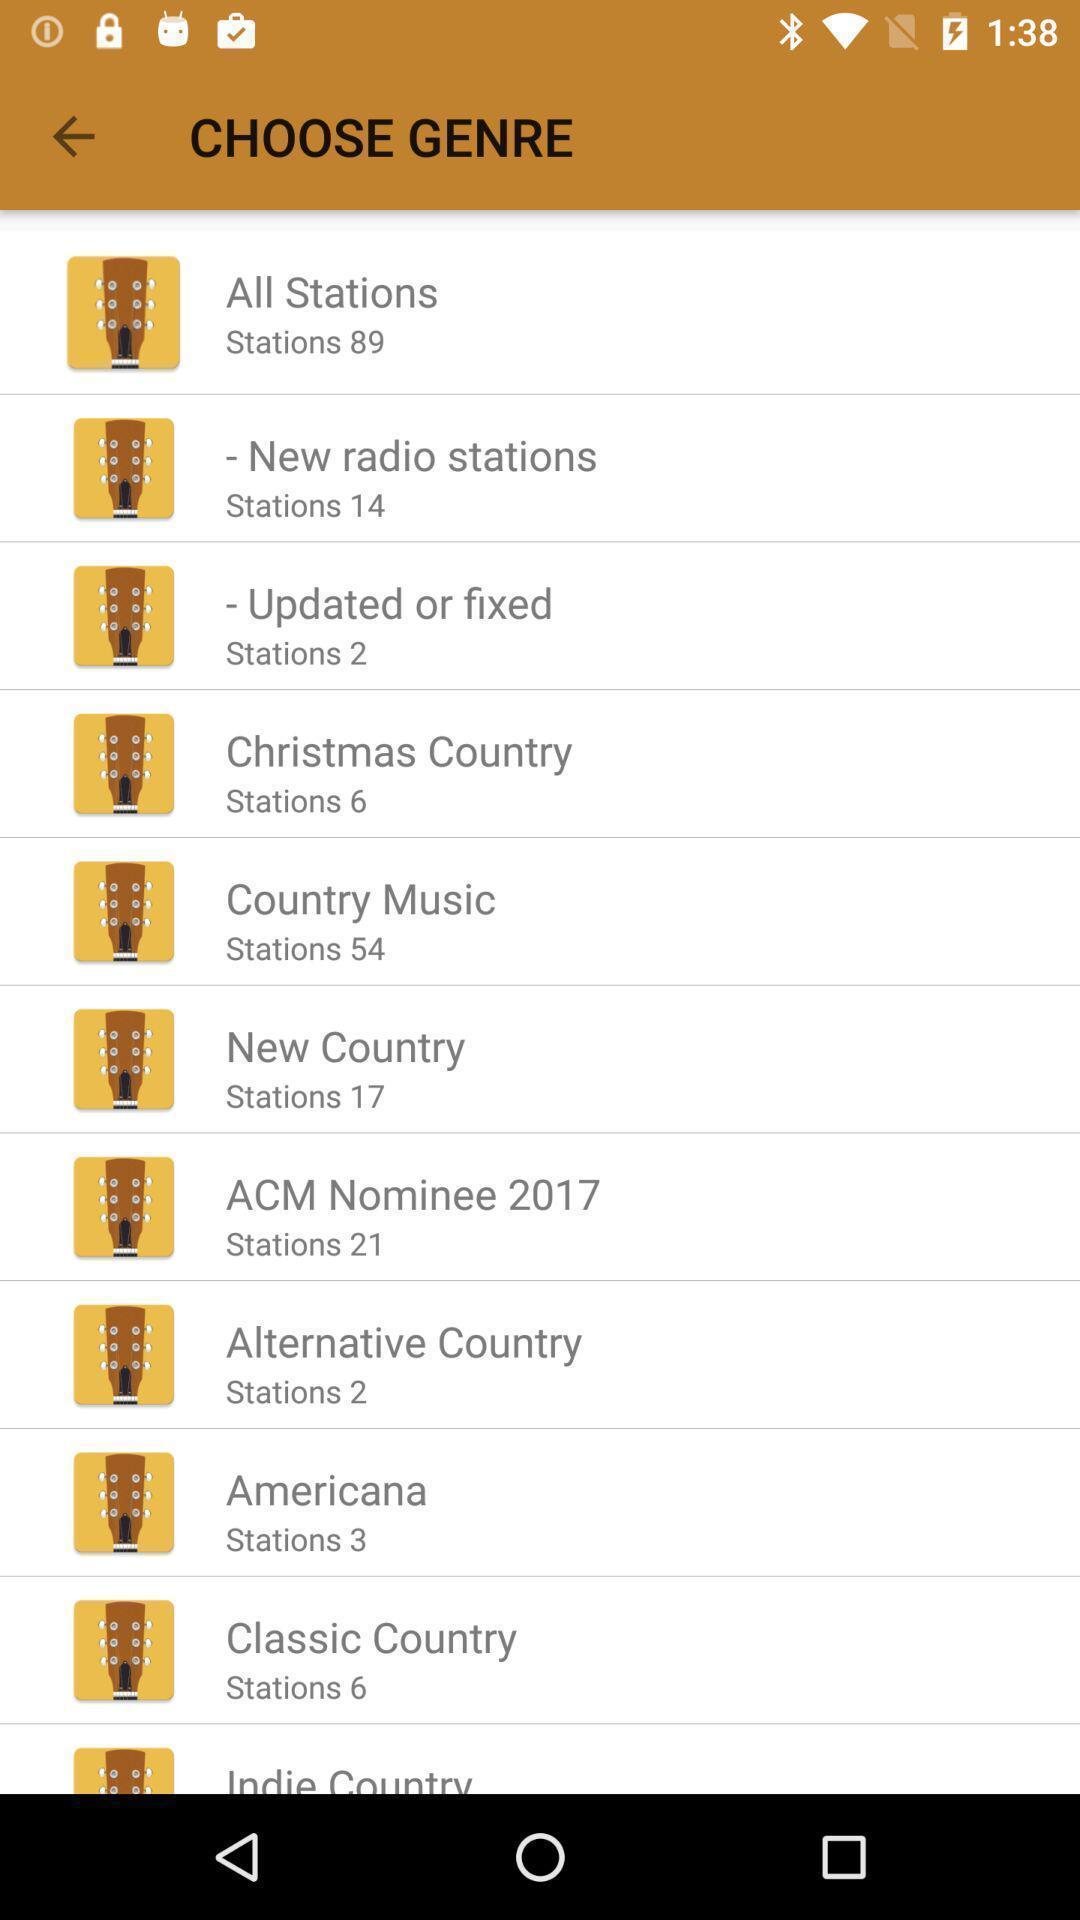Give me a summary of this screen capture. Screen displaying the list of genres to choose. 